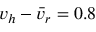Convert formula to latex. <formula><loc_0><loc_0><loc_500><loc_500>v _ { h } - \bar { v } _ { r } = 0 . 8</formula> 